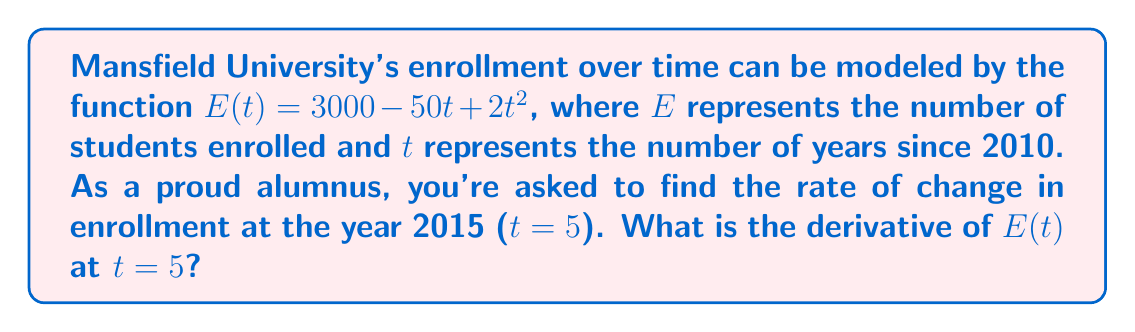Can you answer this question? To find the rate of change in enrollment at t = 5, we need to follow these steps:

1. Find the derivative of $E(t)$:
   $$E(t) = 3000 - 50t + 2t^2$$
   $$E'(t) = -50 + 4t$$ (using the power rule and constant rule)

2. Evaluate the derivative at t = 5:
   $$E'(5) = -50 + 4(5)$$
   $$E'(5) = -50 + 20$$
   $$E'(5) = -30$$

The negative value indicates that the enrollment is decreasing at this point in time.
Answer: $-30$ students per year 